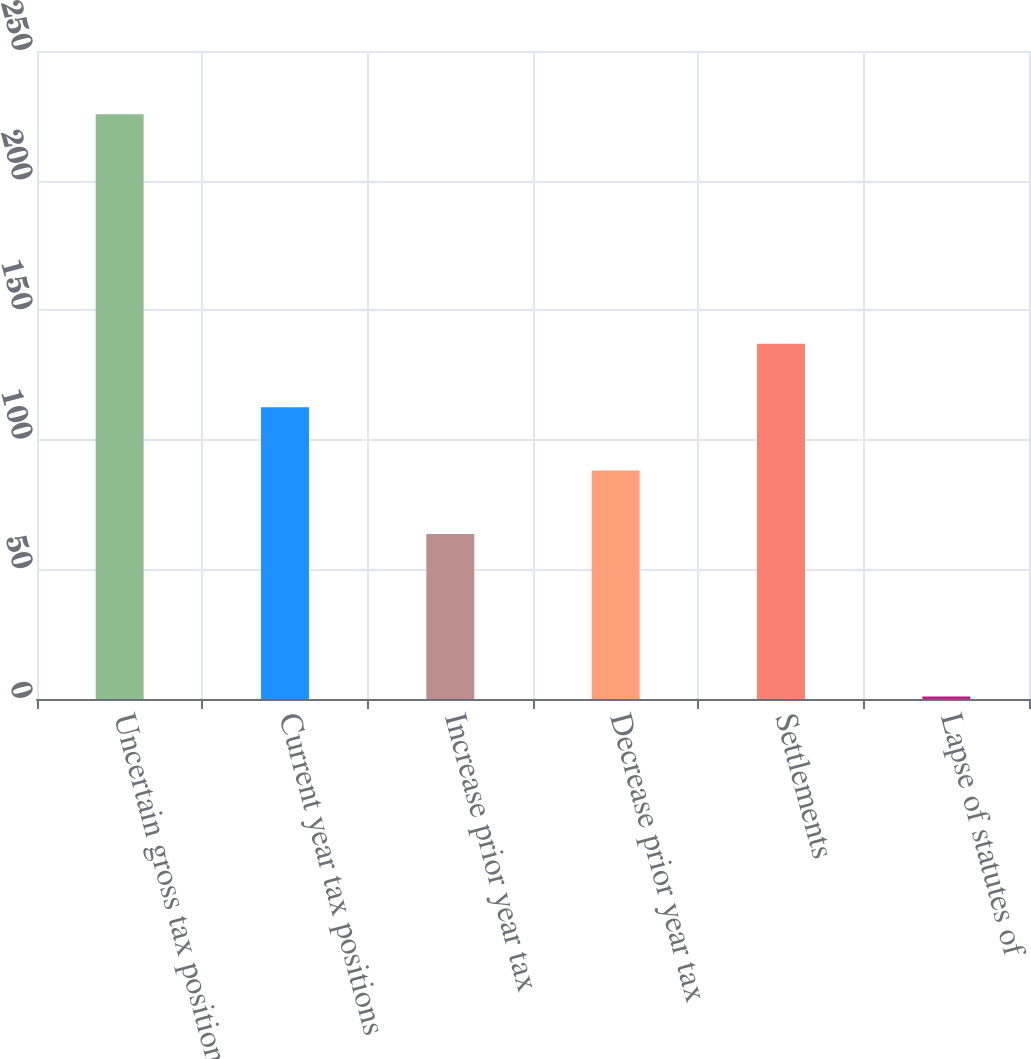<chart> <loc_0><loc_0><loc_500><loc_500><bar_chart><fcel>Uncertain gross tax positions<fcel>Current year tax positions<fcel>Increase prior year tax<fcel>Decrease prior year tax<fcel>Settlements<fcel>Lapse of statutes of<nl><fcel>225.6<fcel>112.6<fcel>63.7<fcel>88.15<fcel>137.05<fcel>1<nl></chart> 